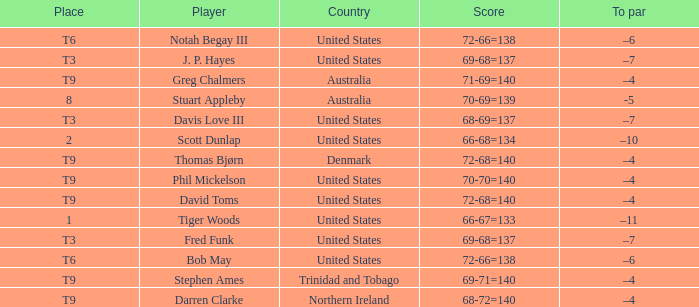What is the To par value that goes with a Score of 70-69=139? -5.0. 